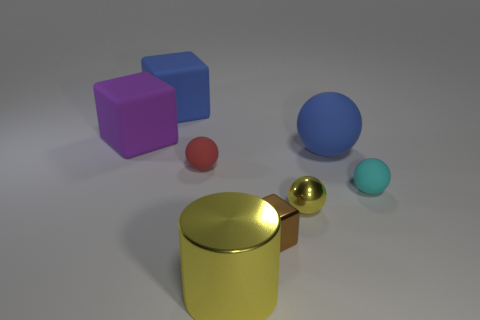Subtract all brown spheres. Subtract all cyan cylinders. How many spheres are left? 4 Subtract all red cylinders. How many blue blocks are left? 1 Add 7 reds. How many large objects exist? 0 Subtract all tiny brown shiny cubes. Subtract all small purple things. How many objects are left? 7 Add 3 big purple rubber objects. How many big purple rubber objects are left? 4 Add 1 large blue matte spheres. How many large blue matte spheres exist? 2 Add 2 big blue rubber balls. How many objects exist? 10 Subtract all blue balls. How many balls are left? 3 Subtract all cyan rubber balls. How many balls are left? 3 Subtract 0 purple cylinders. How many objects are left? 8 